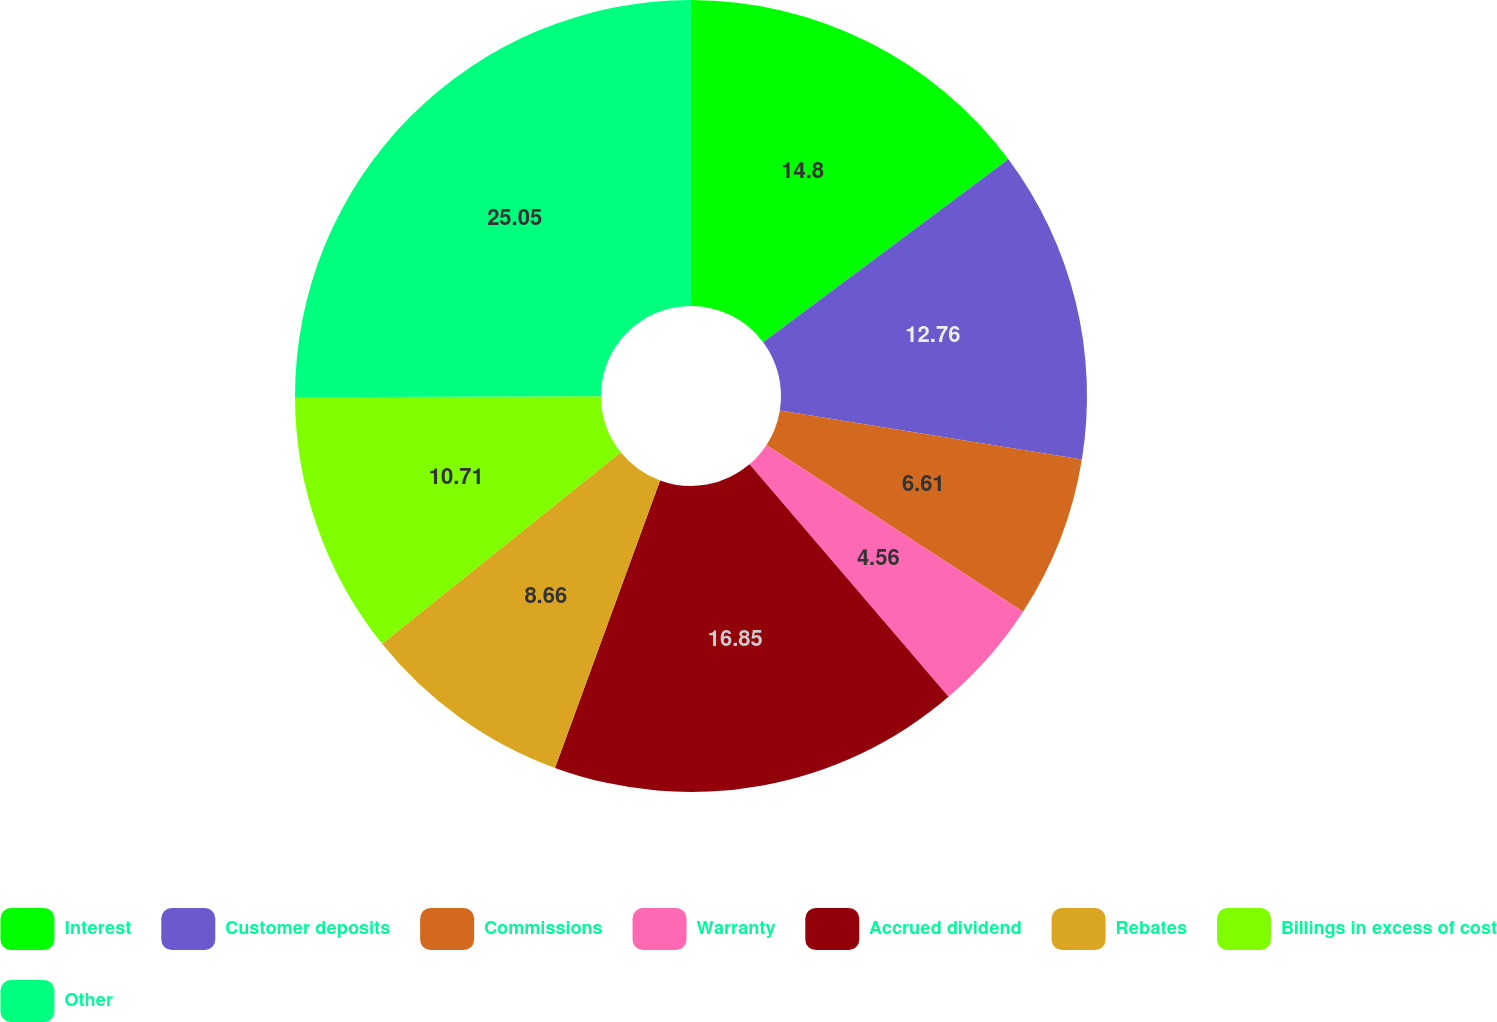Convert chart. <chart><loc_0><loc_0><loc_500><loc_500><pie_chart><fcel>Interest<fcel>Customer deposits<fcel>Commissions<fcel>Warranty<fcel>Accrued dividend<fcel>Rebates<fcel>Billings in excess of cost<fcel>Other<nl><fcel>14.8%<fcel>12.76%<fcel>6.61%<fcel>4.56%<fcel>16.85%<fcel>8.66%<fcel>10.71%<fcel>25.05%<nl></chart> 